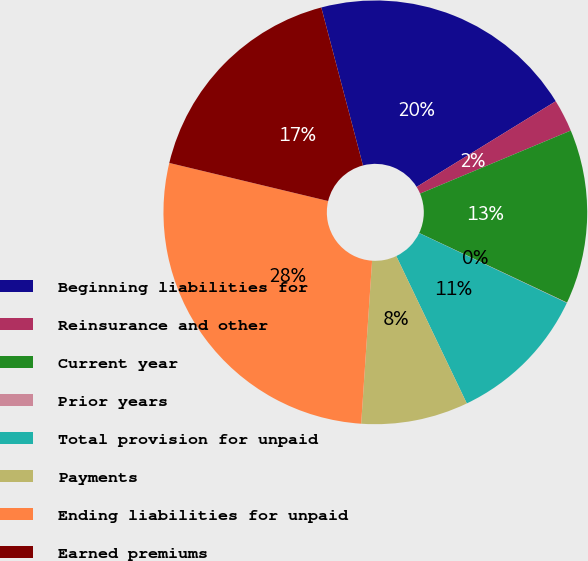Convert chart to OTSL. <chart><loc_0><loc_0><loc_500><loc_500><pie_chart><fcel>Beginning liabilities for<fcel>Reinsurance and other<fcel>Current year<fcel>Prior years<fcel>Total provision for unpaid<fcel>Payments<fcel>Ending liabilities for unpaid<fcel>Earned premiums<nl><fcel>20.32%<fcel>2.48%<fcel>13.31%<fcel>0.03%<fcel>10.86%<fcel>8.17%<fcel>27.68%<fcel>17.15%<nl></chart> 